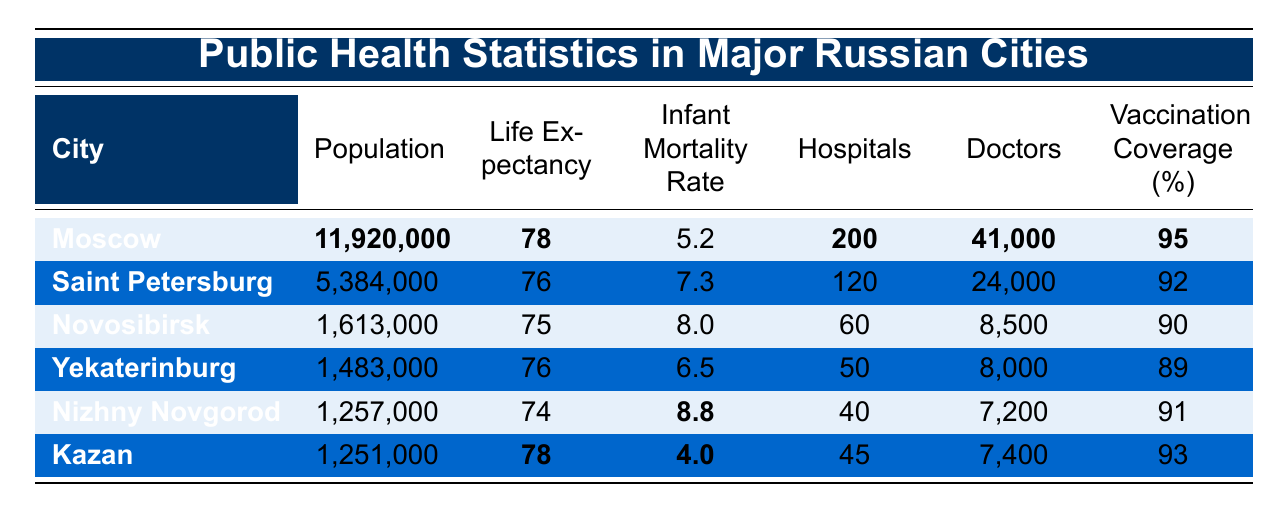What is the life expectancy in Moscow? The life expectancy value for Moscow is explicitly stated in the table, highlighted in bold, as 78 years.
Answer: 78 Which city has the highest infant mortality rate? By comparing the infant mortality rates listed for each city, Nizhny Novgorod, with a rate of 8.8, has the highest value.
Answer: Nizhny Novgorod How many hospitals are there in Saint Petersburg? The number of hospitals in Saint Petersburg is provided in the table and is 120, which is shown as a regular value.
Answer: 120 What is the vaccination coverage for Kazan? The vaccination coverage percentage for Kazan is presented in the table as 93%, which is in regular text but information can be easily retrieved.
Answer: 93 Who has more doctors: Moscow or Saint Petersburg? Moscow has 41,000 doctors and Saint Petersburg has 24,000. Comparing these two values, Moscow has more doctors than Saint Petersburg.
Answer: Moscow What is the total number of hospitals in Novosibirsk and Yekaterinburg combined? The number of hospitals in Novosibirsk is 60, and in Yekaterinburg, it is 50. Adding these together gives 60 + 50 = 110 as the total.
Answer: 110 Is the life expectancy in Novosibirsk higher than in Yekaterinburg? The life expectancy in Novosibirsk is 75 while Yekaterinburg's is 76. Therefore, Novosibirsk's life expectancy is lower than Yekaterinburg's.
Answer: No Which city has the lowest population? The populations of all the cities are presented; Novosibirsk has the lowest population at 1,613,000, which is noted when comparing all values.
Answer: Novosibirsk What is the average life expectancy of the cities listed? The life expectancy values are 78, 76, 75, 76, 74, and 78. Summing these gives 78+76+75+76+74+78 = 457, and dividing by 6 gives an average of 76.17.
Answer: 76.17 Are there more hospitals in Moscow than the average number of hospitals across all cities? Moscow has 200 hospitals. The total number of hospitals across all cities is (200 + 120 + 60 + 50 + 40 + 45) = 615. The average is 615 / 6 = 102.5. Since 200 is greater than 102.5, the answer is yes.
Answer: Yes 